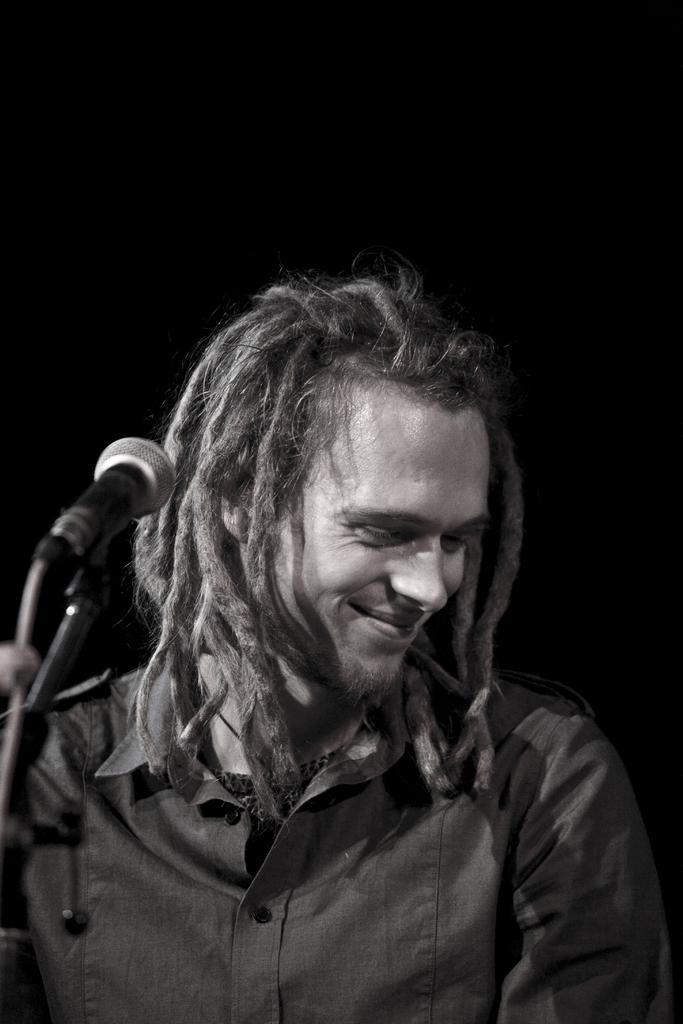Please provide a concise description of this image. In this picture I can observe a man in the middle of the picture. On the left side I can observe a mic. The background is completely dark. 